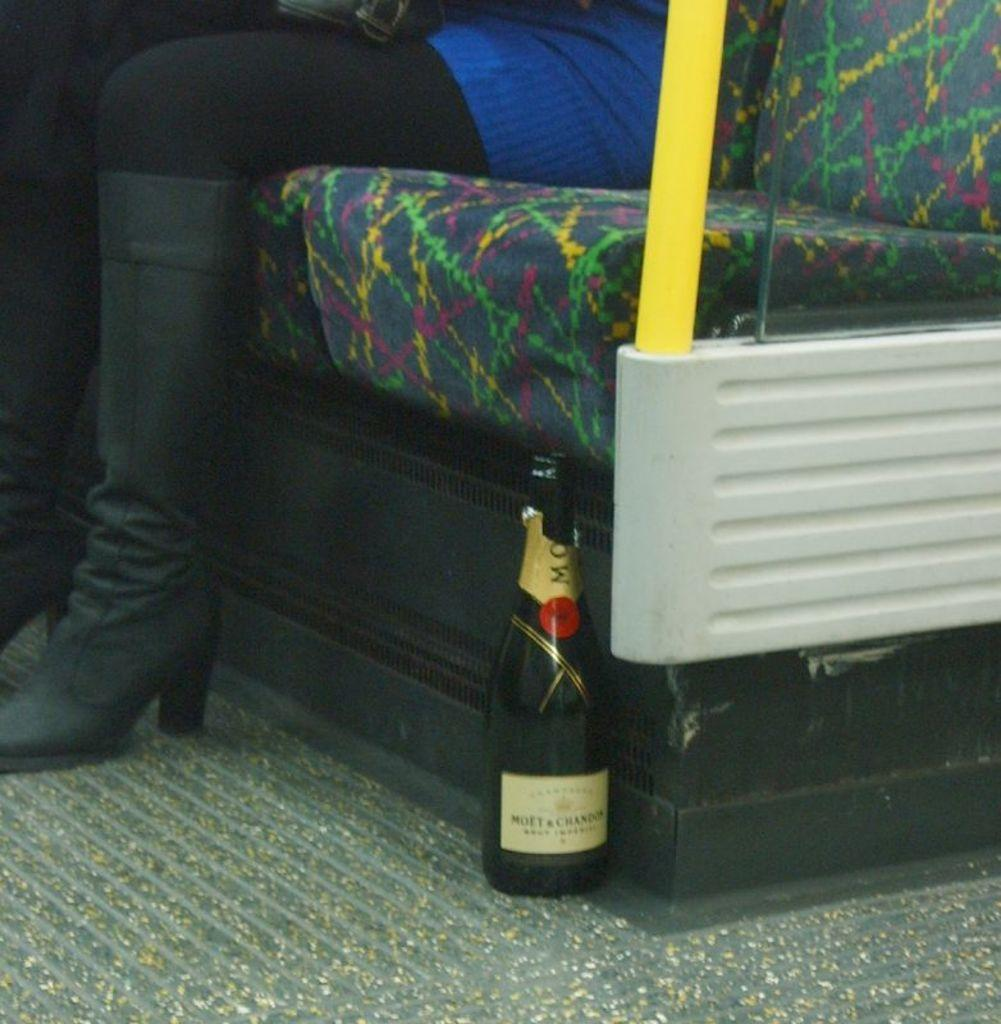What is the main object in the center of the image? There is a bottle in the center of the image. Who is present in the image? There is a lady in the image. What is the lady doing in the image? The lady is sitting on a seat. Where is the seat located in the image? The seat is located at the top side of the image. What type of reward can be seen erupting from the volcano in the image? There is no volcano present in the image, so it is not possible to answer that question. 